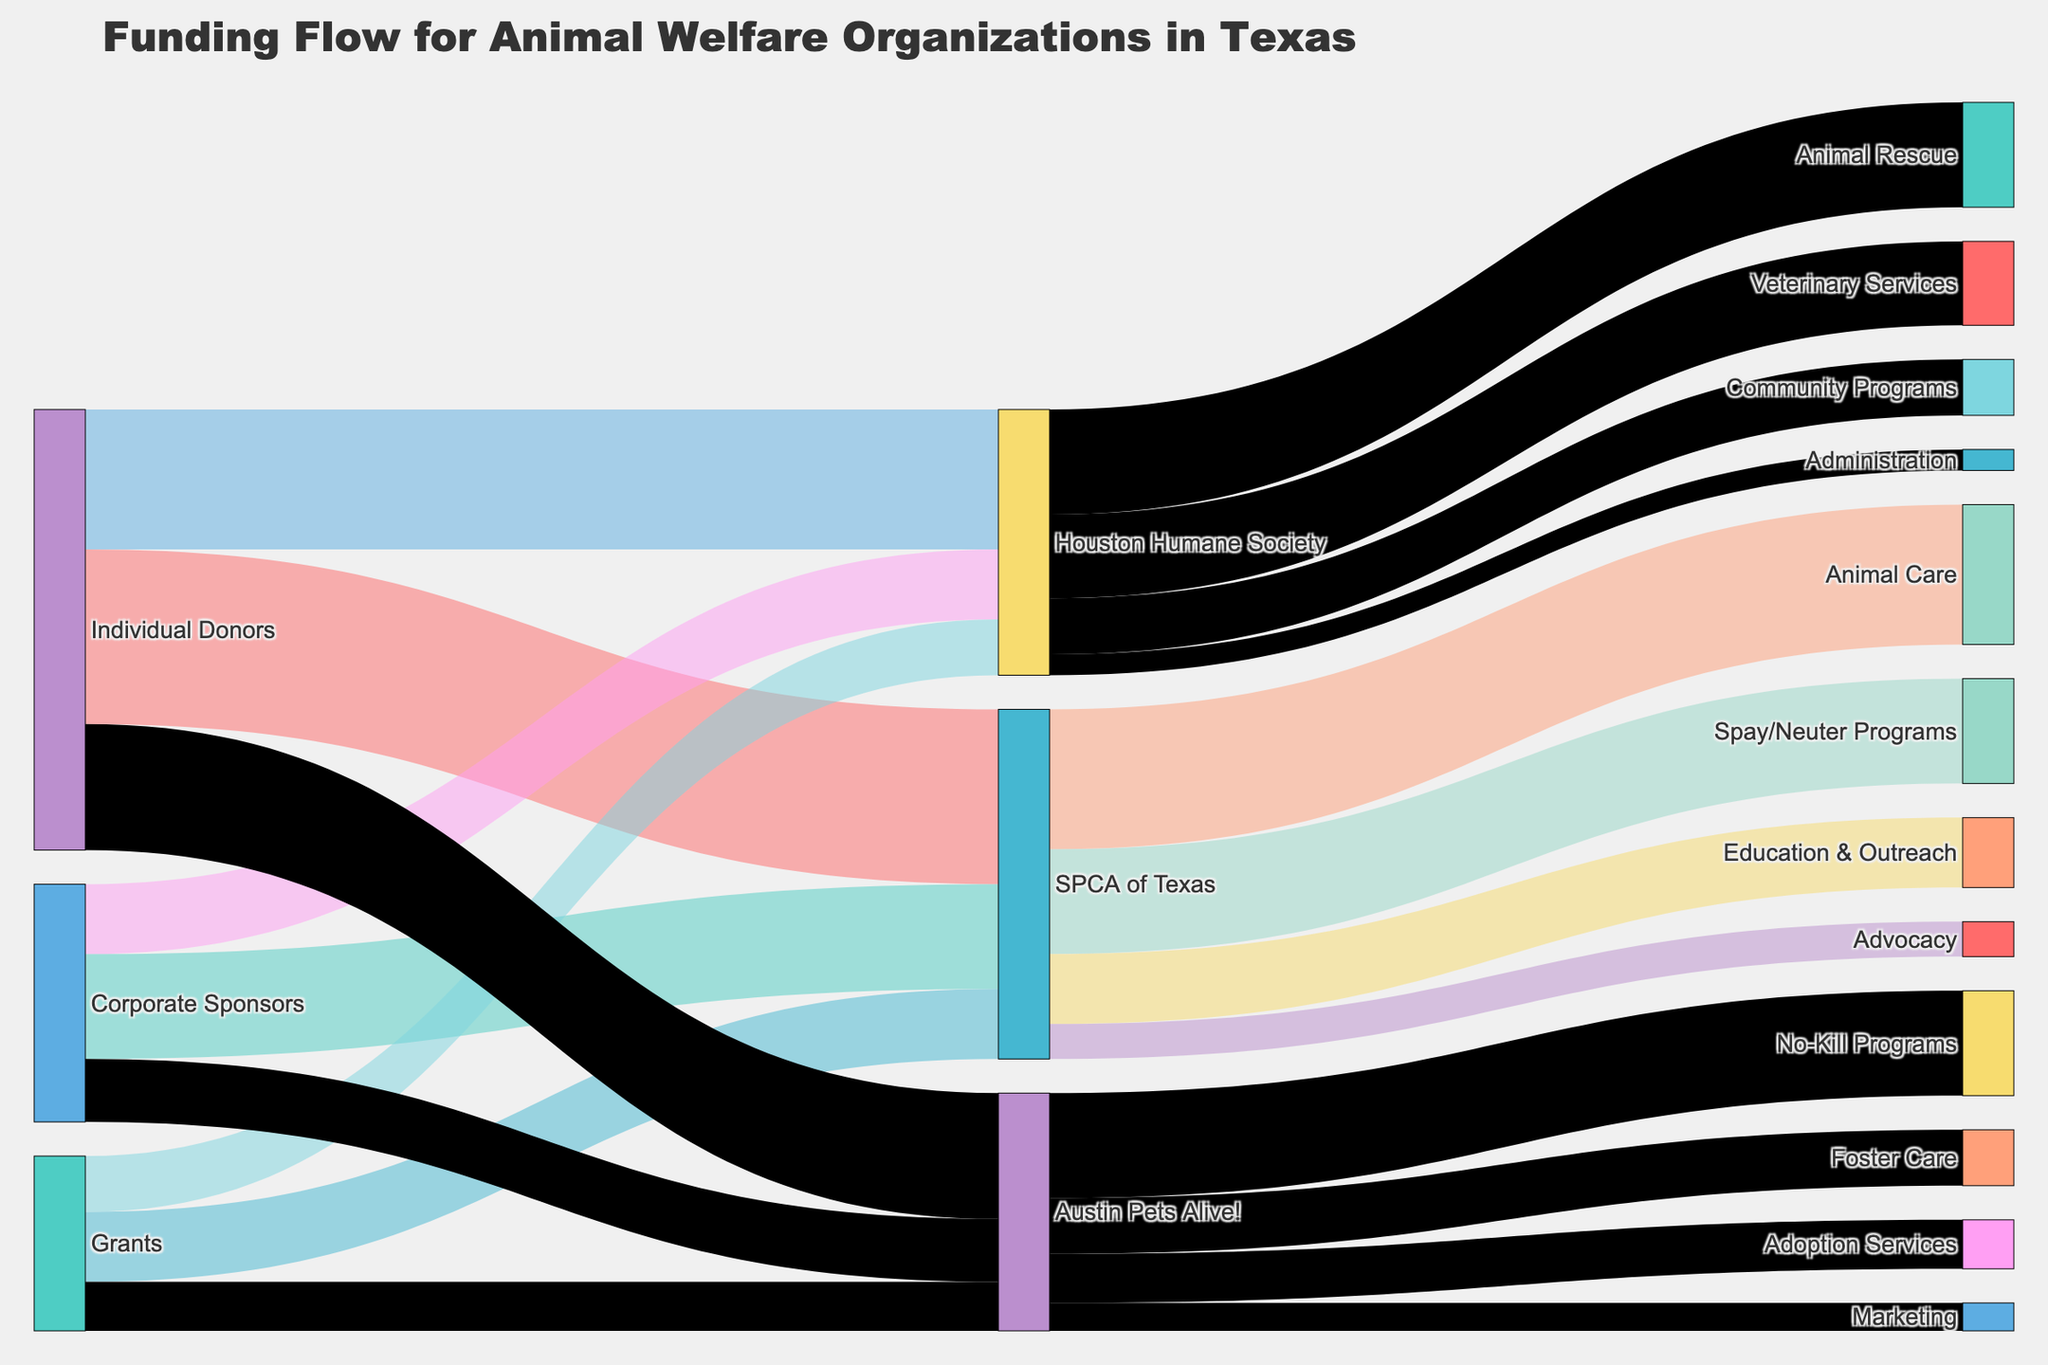What's the total funding received by SPCA of Texas? To find this, sum up all the funding amounts associated with SPCA of Texas from the Individual Donors, Corporate Sponsors, and Grants. So, that's $2,500,000 + $1,500,000 + $1,000,000.
Answer: $5,000,000 Which organization received the most funding from Individual Donors? Look at the figures for each organization under "Individual Donors." SPCA of Texas received $2,500,000, Houston Humane Society received $2,000,000, and Austin Pets Alive! received $1,800,000. SPCA of Texas received the most funding from Individual Donors.
Answer: SPCA of Texas How much funding was allocated for Veterinary Services by the Houston Humane Society? Track the flow of funds from "Houston Humane Society" to "Veterinary Services" which is $1,200,000 as indicated.
Answer: $1,200,000 What is the total funding allocated towards animal care and rescue across all organizations? Add the amounts labeled for "Animal Care" and "Animal Rescue" across all organizations. SPCA of Texas: $2,000,000 for Animal Care, Houston Humane Society: $1,500,000 for Animal Rescue. So, the total is $2,000,000 + $1,500,000.
Answer: $3,500,000 Which category received the least funding from Austin Pets Alive!? Check the allocation of funds from Austin Pets Alive! to different categories. The lowest amount is allocated to Marketing, with $400,000.
Answer: Marketing Compare the funding for Spay/Neuter Programs at SPCA of Texas with the amount for No-Kill Programs at Austin Pets Alive!. Which one is higher? Compare the amounts allocated: Spay/Neuter Programs at SPCA of Texas received $1,500,000 and No-Kill Programs at Austin Pets Alive! received $1,500,000. Both are equal in funding.
Answer: Equal What percentage of the total funding received by Houston Humane Society is allocated to Community Programs? Total funding for Houston Humane Society is $2,000,000 (Individual Donors) + $1,000,000 (Corporate Sponsors) + $800,000 (Grants) = $3,800,000. Funding for Community Programs is $800,000. Percentage = ($800,000 / $3,800,000) * 100 = 21.05%.
Answer: 21.05% Rank the funding allocations for SPCA of Texas from highest to lowest. SPCA of Texas has funding allocations as follows: Animal Care ($2,000,000), Spay/Neuter Programs ($1,500,000), Education & Outreach ($1,000,000), and Advocacy ($500,000).
Answer: Animal Care, Spay/Neuter Programs, Education & Outreach, Advocacy 